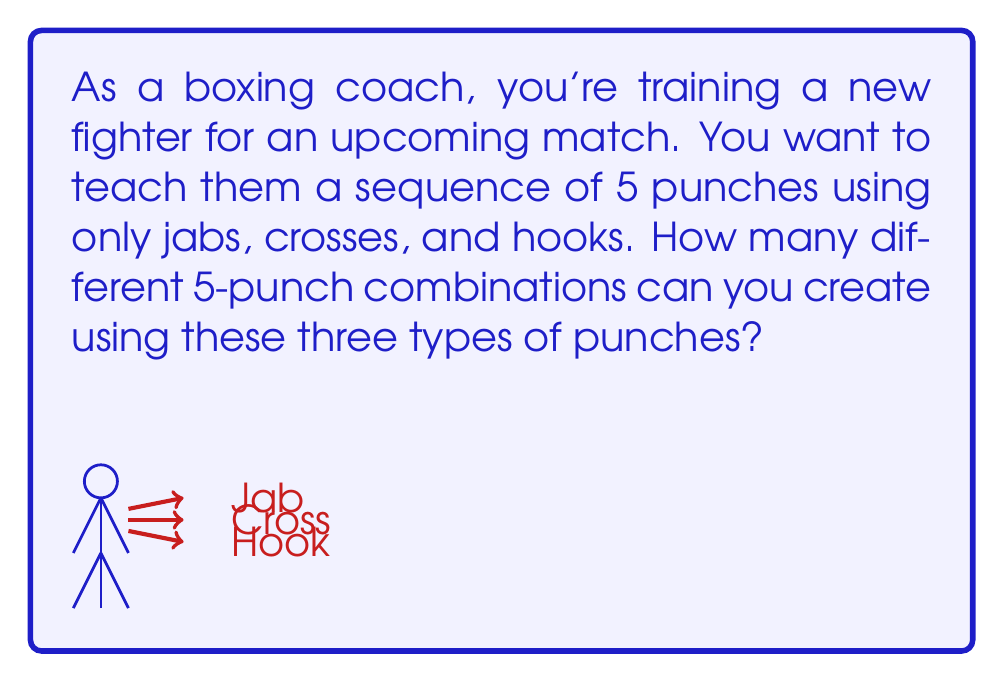Could you help me with this problem? Let's approach this step-by-step:

1) First, we need to understand what this problem is asking. We're creating a sequence of 5 punches, and for each punch, we have 3 choices (jab, cross, or hook).

2) This is a perfect scenario for using the multiplication principle of counting. When we have a series of independent choices, we multiply the number of options for each choice.

3) In this case, we have:
   - 3 choices for the first punch
   - 3 choices for the second punch
   - 3 choices for the third punch
   - 3 choices for the fourth punch
   - 3 choices for the fifth punch

4) Using the multiplication principle, we multiply these together:

   $$3 \times 3 \times 3 \times 3 \times 3 = 3^5$$

5) We can calculate this:

   $$3^5 = 3 \times 3 \times 3 \times 3 \times 3 = 243$$

Therefore, there are 243 different 5-punch combinations possible using jabs, crosses, and hooks.
Answer: $3^5 = 243$ combinations 